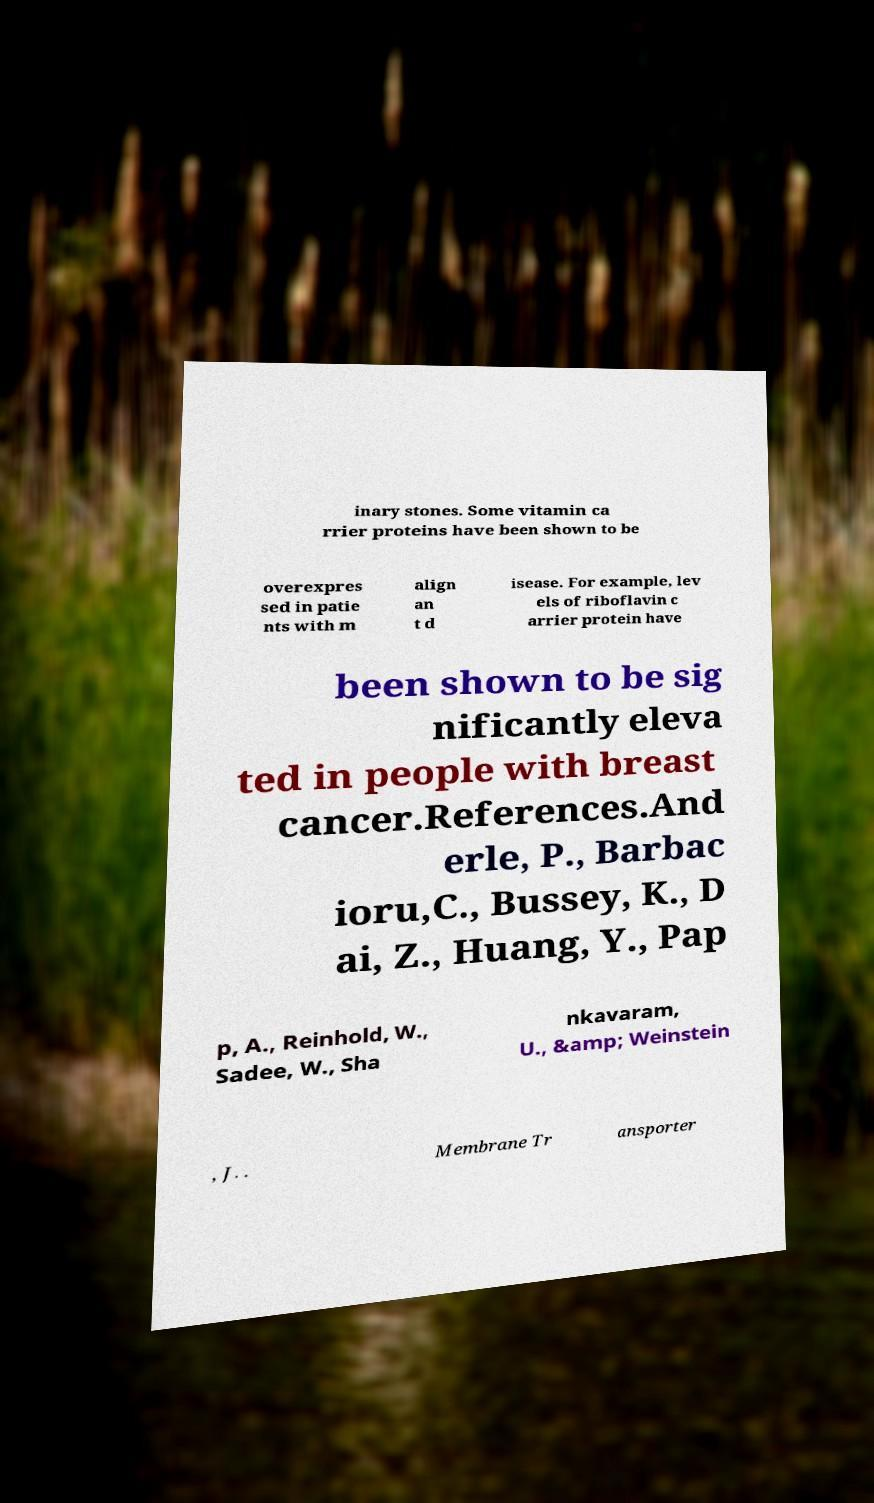I need the written content from this picture converted into text. Can you do that? inary stones. Some vitamin ca rrier proteins have been shown to be overexpres sed in patie nts with m align an t d isease. For example, lev els of riboflavin c arrier protein have been shown to be sig nificantly eleva ted in people with breast cancer.References.And erle, P., Barbac ioru,C., Bussey, K., D ai, Z., Huang, Y., Pap p, A., Reinhold, W., Sadee, W., Sha nkavaram, U., &amp; Weinstein , J. . Membrane Tr ansporter 